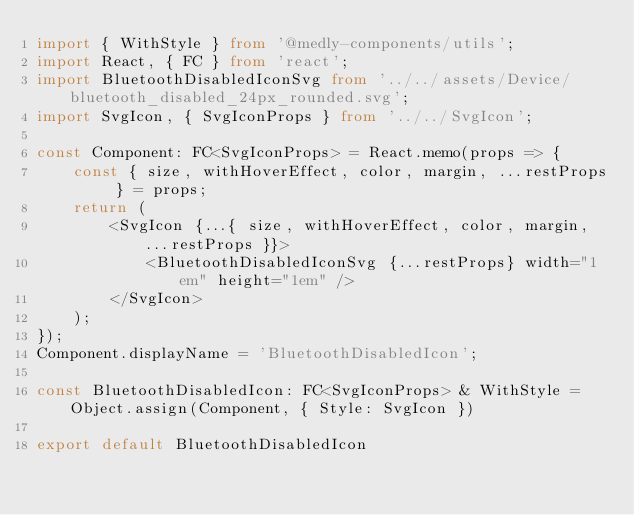Convert code to text. <code><loc_0><loc_0><loc_500><loc_500><_TypeScript_>import { WithStyle } from '@medly-components/utils';
import React, { FC } from 'react';
import BluetoothDisabledIconSvg from '../../assets/Device/bluetooth_disabled_24px_rounded.svg';
import SvgIcon, { SvgIconProps } from '../../SvgIcon';

const Component: FC<SvgIconProps> = React.memo(props => {
    const { size, withHoverEffect, color, margin, ...restProps } = props;
    return (
        <SvgIcon {...{ size, withHoverEffect, color, margin, ...restProps }}>
            <BluetoothDisabledIconSvg {...restProps} width="1em" height="1em" />
        </SvgIcon>
    );
});
Component.displayName = 'BluetoothDisabledIcon';

const BluetoothDisabledIcon: FC<SvgIconProps> & WithStyle = Object.assign(Component, { Style: SvgIcon })

export default BluetoothDisabledIcon
</code> 